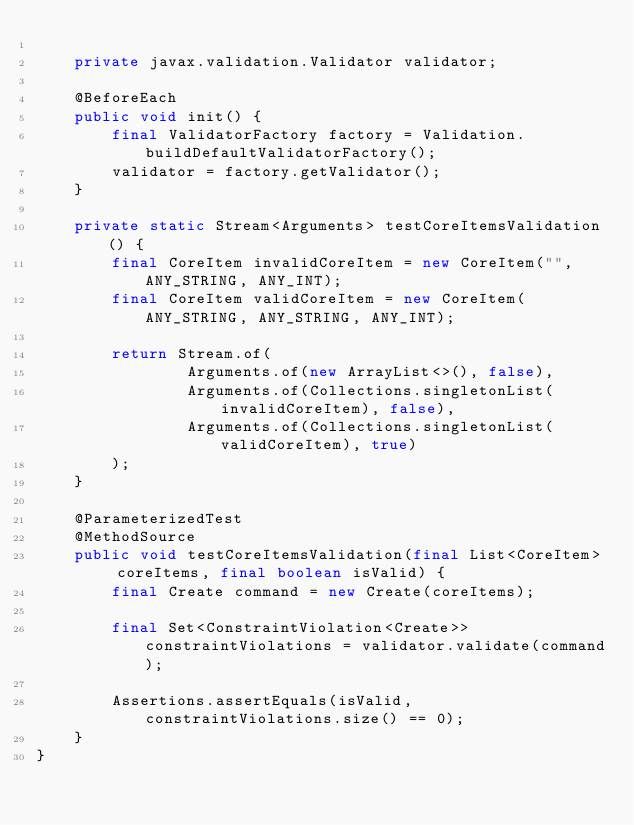Convert code to text. <code><loc_0><loc_0><loc_500><loc_500><_Java_>
    private javax.validation.Validator validator;

    @BeforeEach
    public void init() {
        final ValidatorFactory factory = Validation.buildDefaultValidatorFactory();
        validator = factory.getValidator();
    }

    private static Stream<Arguments> testCoreItemsValidation() {
        final CoreItem invalidCoreItem = new CoreItem("", ANY_STRING, ANY_INT);
        final CoreItem validCoreItem = new CoreItem(ANY_STRING, ANY_STRING, ANY_INT);

        return Stream.of(
                Arguments.of(new ArrayList<>(), false),
                Arguments.of(Collections.singletonList(invalidCoreItem), false),
                Arguments.of(Collections.singletonList(validCoreItem), true)
        );
    }

    @ParameterizedTest
    @MethodSource
    public void testCoreItemsValidation(final List<CoreItem> coreItems, final boolean isValid) {
        final Create command = new Create(coreItems);

        final Set<ConstraintViolation<Create>> constraintViolations = validator.validate(command);

        Assertions.assertEquals(isValid, constraintViolations.size() == 0);
    }
}
</code> 